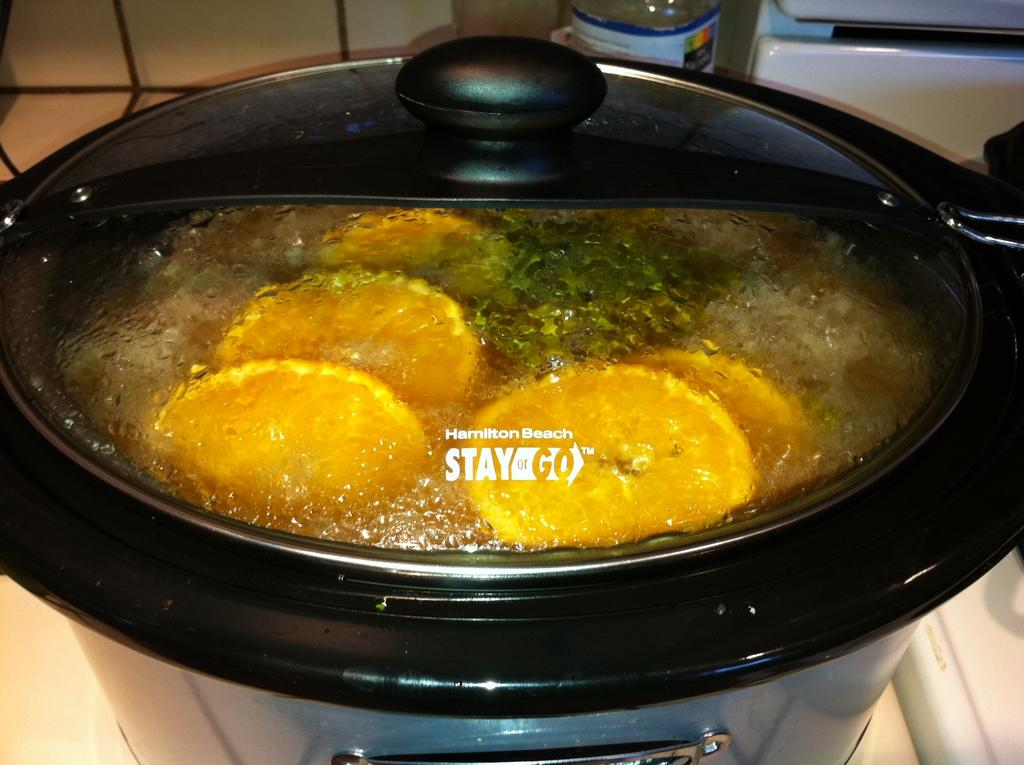<image>
Give a short and clear explanation of the subsequent image. A Hamilton Beach crock pot full of lemons is cooking on a counter. 